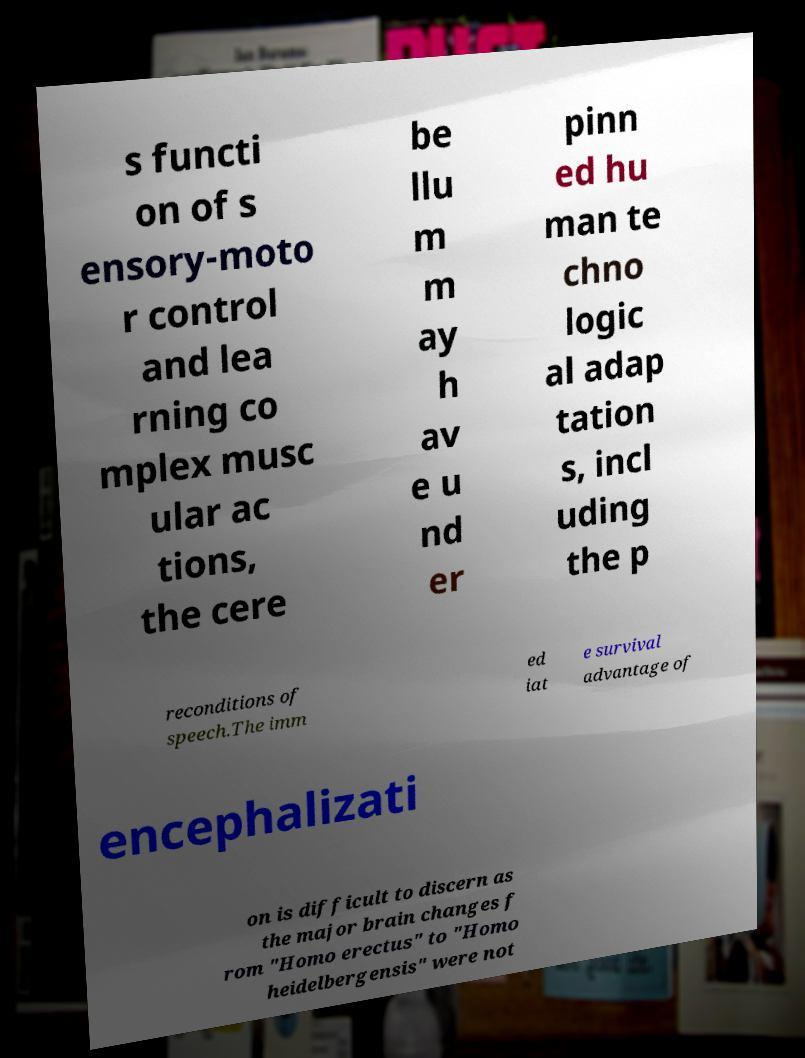Can you accurately transcribe the text from the provided image for me? s functi on of s ensory-moto r control and lea rning co mplex musc ular ac tions, the cere be llu m m ay h av e u nd er pinn ed hu man te chno logic al adap tation s, incl uding the p reconditions of speech.The imm ed iat e survival advantage of encephalizati on is difficult to discern as the major brain changes f rom "Homo erectus" to "Homo heidelbergensis" were not 